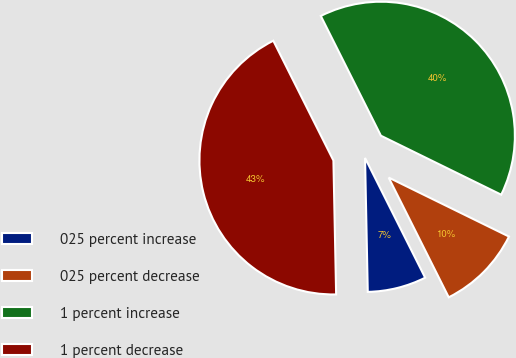Convert chart. <chart><loc_0><loc_0><loc_500><loc_500><pie_chart><fcel>025 percent increase<fcel>025 percent decrease<fcel>1 percent increase<fcel>1 percent decrease<nl><fcel>7.08%<fcel>10.34%<fcel>39.66%<fcel>42.92%<nl></chart> 